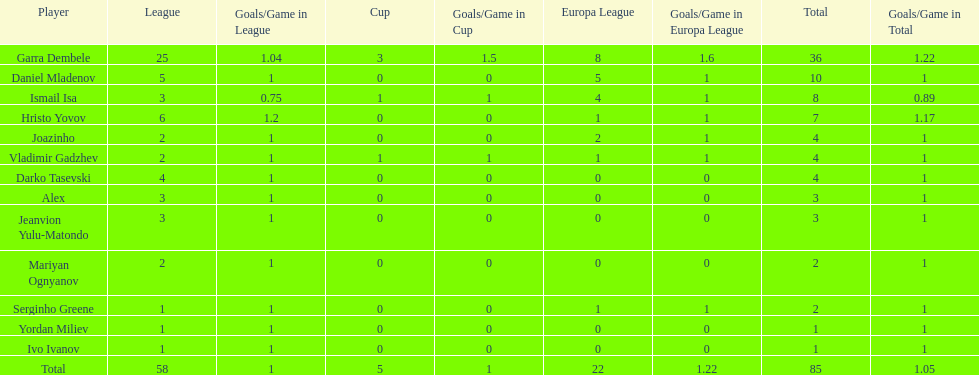Which is the only player from germany? Jeanvion Yulu-Matondo. 